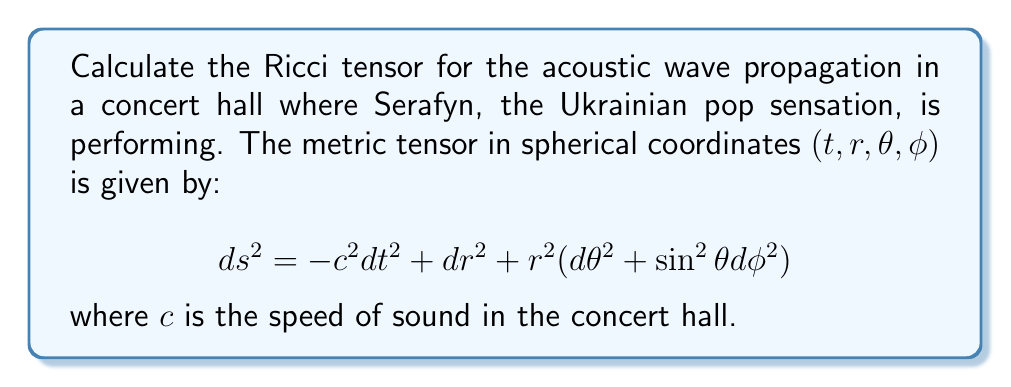Give your solution to this math problem. To compute the Ricci tensor, we'll follow these steps:

1) First, we need to calculate the Christoffel symbols $\Gamma^{\mu}_{\nu\lambda}$ using the metric tensor:

   $$\Gamma^{\mu}_{\nu\lambda} = \frac{1}{2}g^{\mu\sigma}(\partial_\nu g_{\lambda\sigma} + \partial_\lambda g_{\nu\sigma} - \partial_\sigma g_{\nu\lambda})$$

2) The non-zero Christoffel symbols for this metric are:

   $$\Gamma^r_{\theta\theta} = -r$$
   $$\Gamma^r_{\phi\phi} = -r\sin^2\theta$$
   $$\Gamma^\theta_{r\theta} = \Gamma^\phi_{r\phi} = \frac{1}{r}$$
   $$\Gamma^\theta_{\phi\phi} = -\sin\theta\cos\theta$$
   $$\Gamma^\phi_{\theta\phi} = \cot\theta$$

3) Next, we calculate the Riemann curvature tensor:

   $$R^\rho_{\sigma\mu\nu} = \partial_\mu\Gamma^\rho_{\nu\sigma} - \partial_\nu\Gamma^\rho_{\mu\sigma} + \Gamma^\rho_{\mu\lambda}\Gamma^\lambda_{\nu\sigma} - \Gamma^\rho_{\nu\lambda}\Gamma^\lambda_{\mu\sigma}$$

4) The non-zero components of the Riemann tensor are:

   $$R^r_{\theta r\theta} = R^r_{\phi r\phi} = -1$$
   $$R^\theta_{\phi\theta\phi} = -\sin^2\theta$$

5) Finally, we compute the Ricci tensor by contracting the Riemann tensor:

   $$R_{\mu\nu} = R^\lambda_{\mu\lambda\nu}$$

6) The non-zero components of the Ricci tensor are:

   $$R_{rr} = -\frac{2}{r^2}$$
   $$R_{\theta\theta} = -1$$
   $$R_{\phi\phi} = -\sin^2\theta$$

Thus, the Ricci tensor in matrix form is:

$$R_{\mu\nu} = \begin{pmatrix}
0 & 0 & 0 & 0 \\
0 & -\frac{2}{r^2} & 0 & 0 \\
0 & 0 & -1 & 0 \\
0 & 0 & 0 & -\sin^2\theta
\end{pmatrix}$$
Answer: $$R_{\mu\nu} = \text{diag}(0, -\frac{2}{r^2}, -1, -\sin^2\theta)$$ 